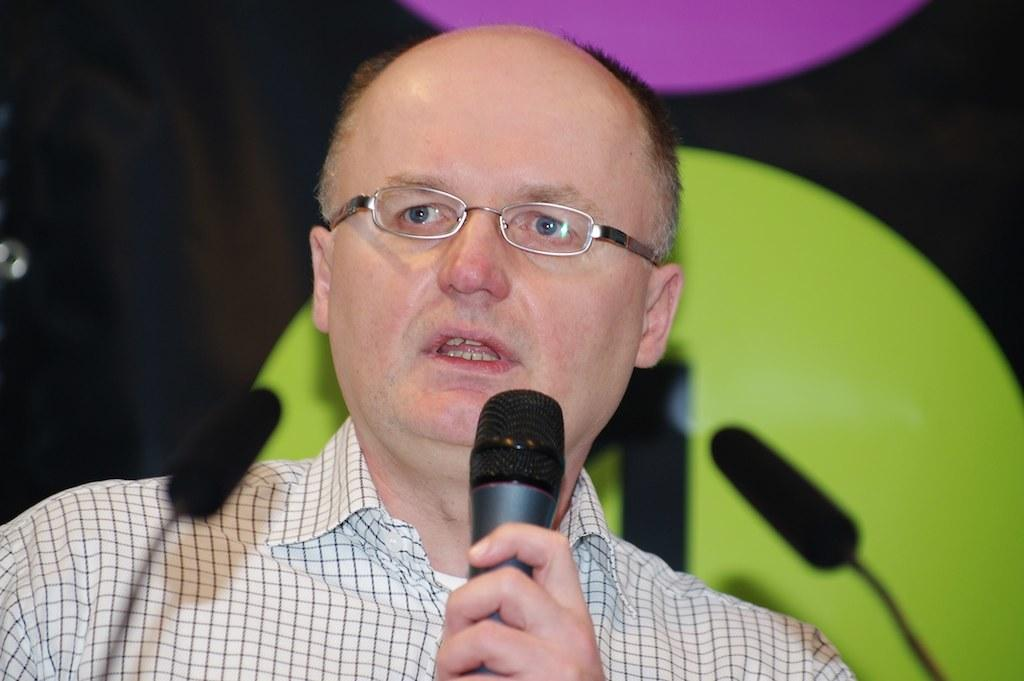What is the man in the image holding in his hand? The man is holding a microphone in his hand. What is the man doing in the image? The man is talking. What can be seen on the man's face in the image? The man is wearing spectacles. What color is the man's shirt in the image? The man's shirt color is white. Are there any patterns on the man's shirt in the image? Yes, there are black color stripes on the man's shirt. What type of rake is the man using to gather leaves in the image? There is no rake present in the image; the man is holding a microphone and talking. 